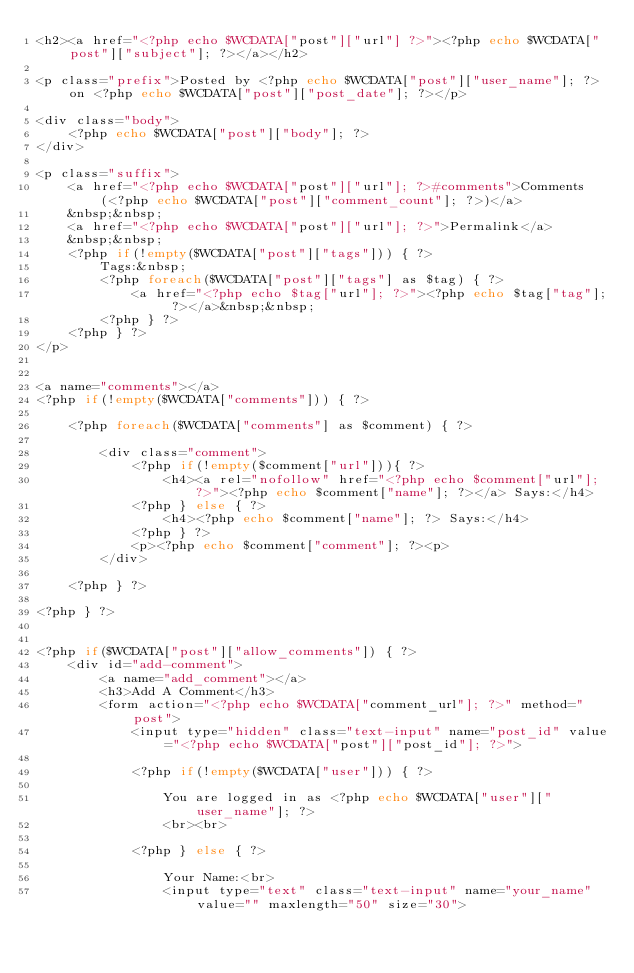<code> <loc_0><loc_0><loc_500><loc_500><_PHP_><h2><a href="<?php echo $WCDATA["post"]["url"] ?>"><?php echo $WCDATA["post"]["subject"]; ?></a></h2>

<p class="prefix">Posted by <?php echo $WCDATA["post"]["user_name"]; ?> on <?php echo $WCDATA["post"]["post_date"]; ?></p>

<div class="body">
    <?php echo $WCDATA["post"]["body"]; ?>
</div>

<p class="suffix">
    <a href="<?php echo $WCDATA["post"]["url"]; ?>#comments">Comments (<?php echo $WCDATA["post"]["comment_count"]; ?>)</a>
    &nbsp;&nbsp;
    <a href="<?php echo $WCDATA["post"]["url"]; ?>">Permalink</a>
    &nbsp;&nbsp;
    <?php if(!empty($WCDATA["post"]["tags"])) { ?>
        Tags:&nbsp;
        <?php foreach($WCDATA["post"]["tags"] as $tag) { ?>
            <a href="<?php echo $tag["url"]; ?>"><?php echo $tag["tag"]; ?></a>&nbsp;&nbsp;
        <?php } ?>
    <?php } ?>
</p>


<a name="comments"></a>
<?php if(!empty($WCDATA["comments"])) { ?>

    <?php foreach($WCDATA["comments"] as $comment) { ?>

        <div class="comment">
            <?php if(!empty($comment["url"])){ ?>
                <h4><a rel="nofollow" href="<?php echo $comment["url"]; ?>"><?php echo $comment["name"]; ?></a> Says:</h4>
            <?php } else { ?>
                <h4><?php echo $comment["name"]; ?> Says:</h4>
            <?php } ?>
            <p><?php echo $comment["comment"]; ?><p>
        </div>

    <?php } ?>

<?php } ?>


<?php if($WCDATA["post"]["allow_comments"]) { ?>
    <div id="add-comment">
        <a name="add_comment"></a>
        <h3>Add A Comment</h3>
        <form action="<?php echo $WCDATA["comment_url"]; ?>" method="post">
            <input type="hidden" class="text-input" name="post_id" value="<?php echo $WCDATA["post"]["post_id"]; ?>">

            <?php if(!empty($WCDATA["user"])) { ?>

                You are logged in as <?php echo $WCDATA["user"]["user_name"]; ?>
                <br><br>

            <?php } else { ?>

                Your Name:<br>
                <input type="text" class="text-input" name="your_name" value="" maxlength="50" size="30"></code> 